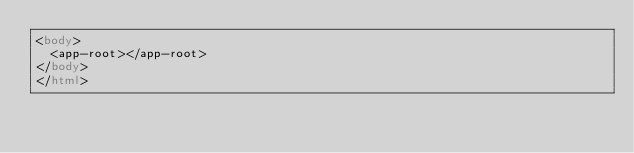<code> <loc_0><loc_0><loc_500><loc_500><_HTML_><body>
  <app-root></app-root>
</body>
</html>
</code> 